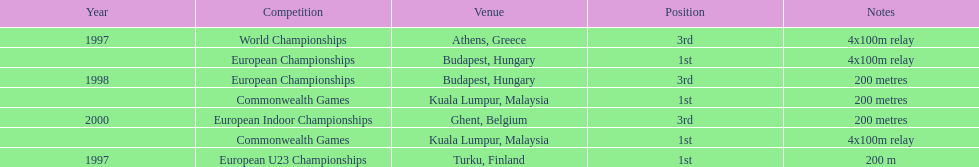List the other competitions besides european u23 championship that came in 1st position? European Championships, Commonwealth Games, Commonwealth Games. 